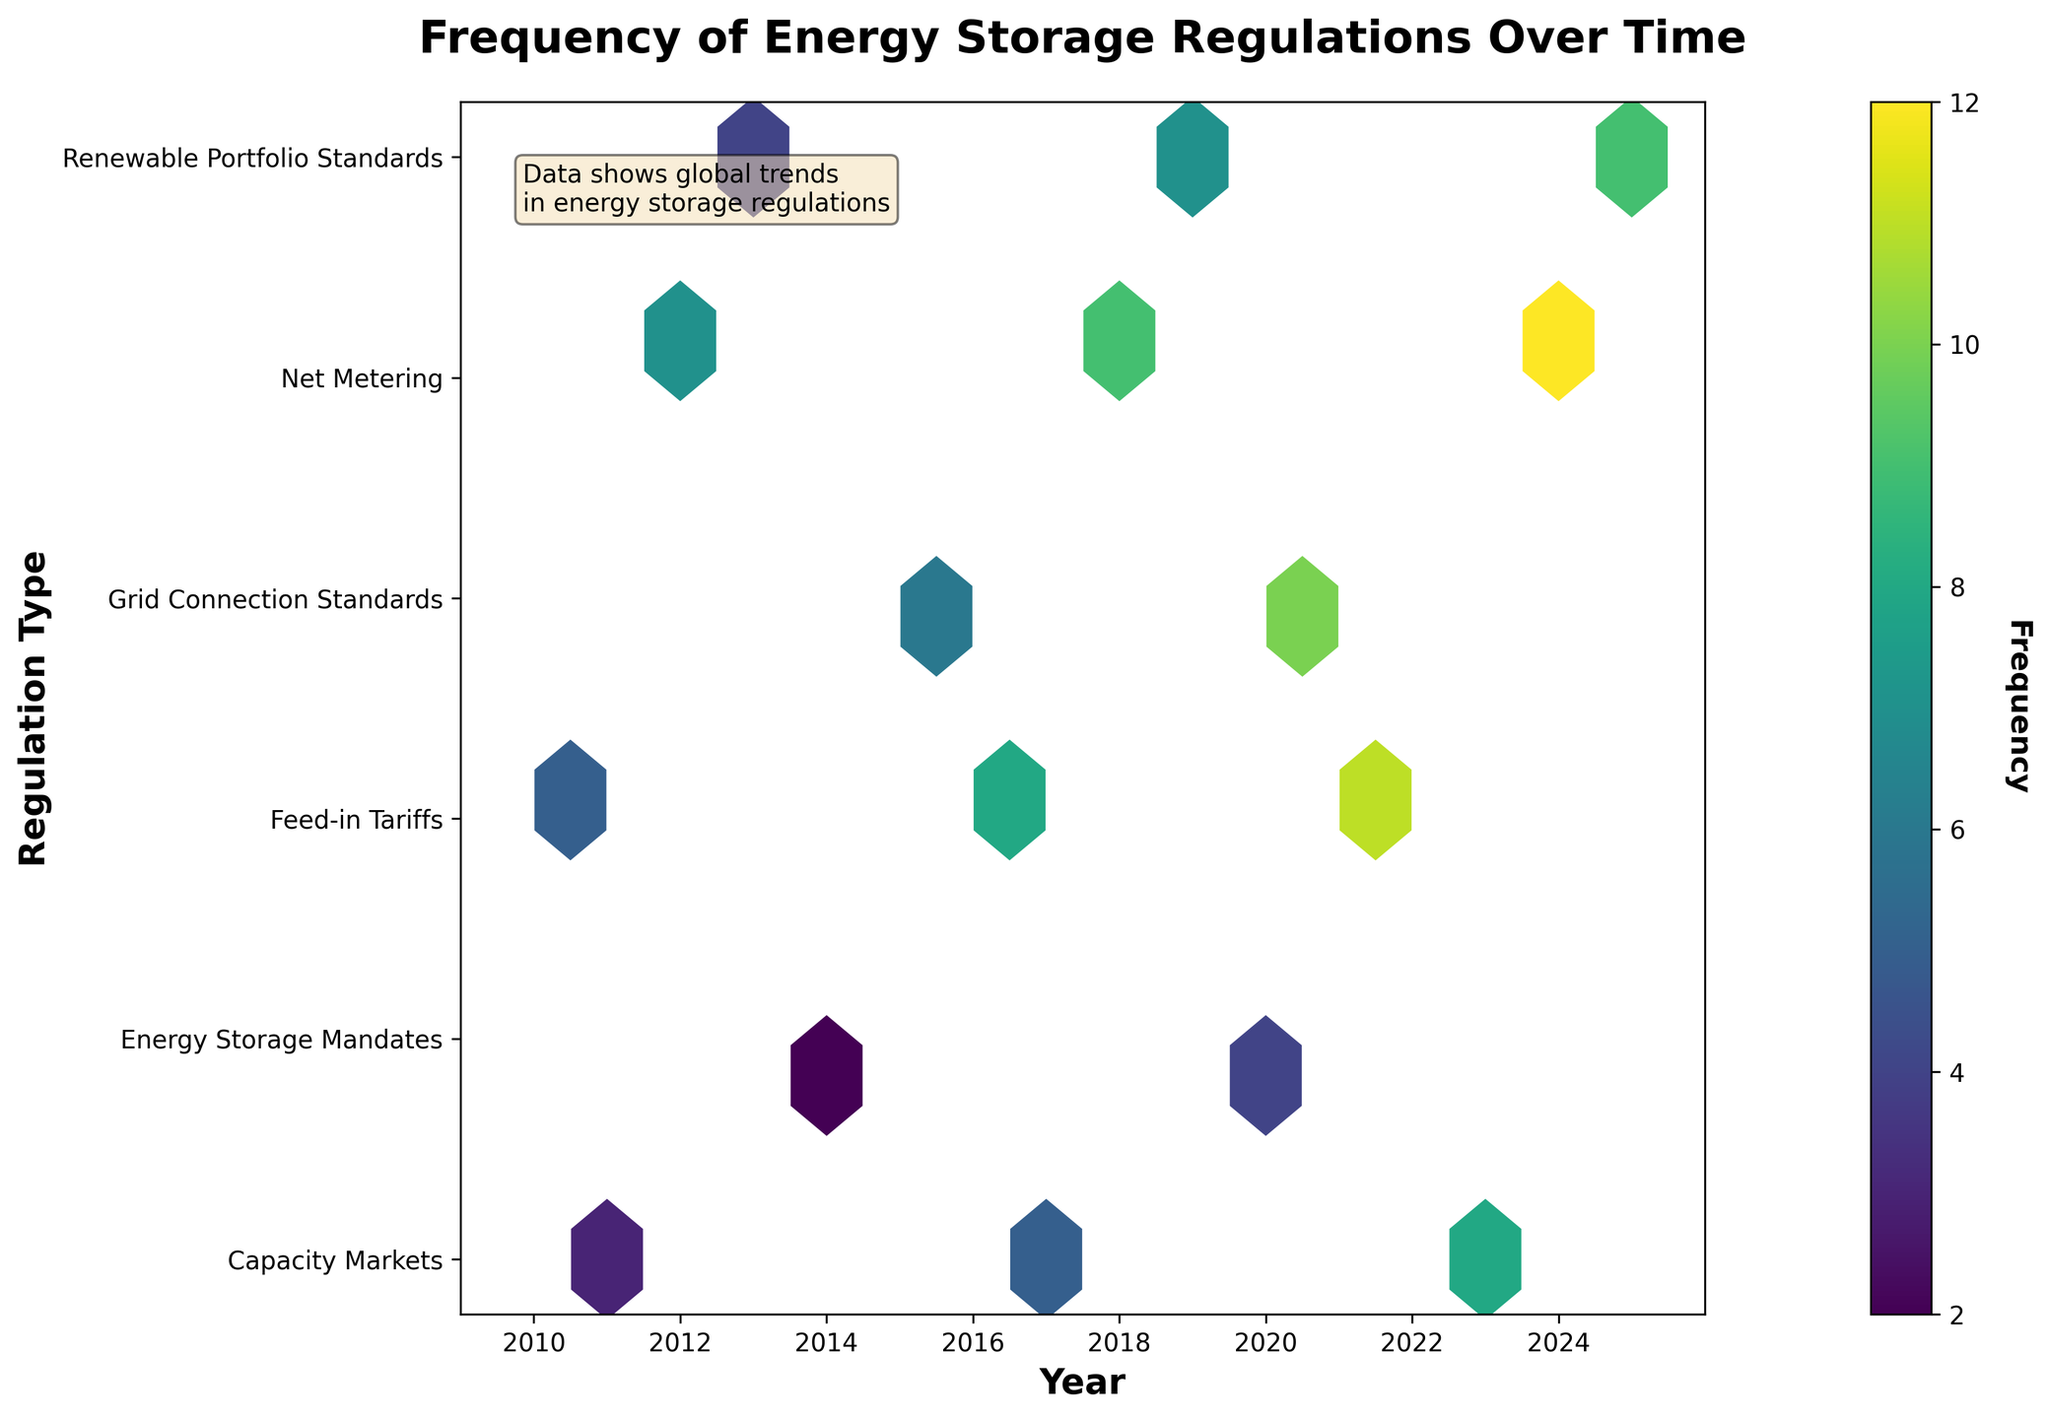What is the title of the figure? The title of the figure can be found at the top of the plot. It reads 'Frequency of Energy Storage Regulations Over Time'.
Answer: Frequency of Energy Storage Regulations Over Time Which regulation type has the highest frequency in 2024? First, locate the year 2024 on the x-axis. Then, find the hexbin corresponding to 2024 and read the y-axis label. The y-axis label for the regulation type with the highest frequency in 2024 is 'Net Metering'.
Answer: Net Metering Which year had the highest frequency of 'Feed-in Tariffs' regulations? Identify the 'Feed-in Tariffs' regulation type on the y-axis. Then look along this row for the hexbin with the highest frequency (darkest color). The year is labeled on the x-axis, which is 2022.
Answer: 2022 What is the difference in the number of 'Energy Storage Mandates' regulations between 2014 and 2020? Locate 'Energy Storage Mandates' on the y-axis and find the hexbin for the years 2014 and 2020 on the x-axis. Read the frequencies for these years (2 for 2014 and 4 for 2020). Subtract the smaller frequency from the larger one (4 - 2 = 2).
Answer: 2 Which regulation type showed a steady increase in frequency from 2012 to 2024? Compare the columns for each regulation type from 2012 to 2024. 'Net Metering' shows a steady increase in frequency over these years.
Answer: Net Metering In which year was the frequency of 'Capacity Markets' equal to 5? Locate 'Capacity Markets' on the y-axis and find the corresponding year on the x-axis where the frequency is labeled as 5. The year is 2017.
Answer: 2017 Compare the frequency of 'Grid Connection Standards' in 2015 and 2021. Which year had a higher frequency? Locate 'Grid Connection Standards' on the y-axis and check the frequencies for 2015 and 2021 on the x-axis. The frequency in 2021 (10) is higher than in 2015 (6).
Answer: 2021 What is the average frequency of 'Renewable Portfolio Standards' over the three listed years (2013, 2019, 2025)? Locate 'Renewable Portfolio Standards' on the y-axis and read the frequencies for the years 2013 (4), 2019 (7), and 2025 (9). Calculate the average: (4 + 7 + 9) / 3 = 20 / 3 ≈ 6.67.
Answer: 6.67 